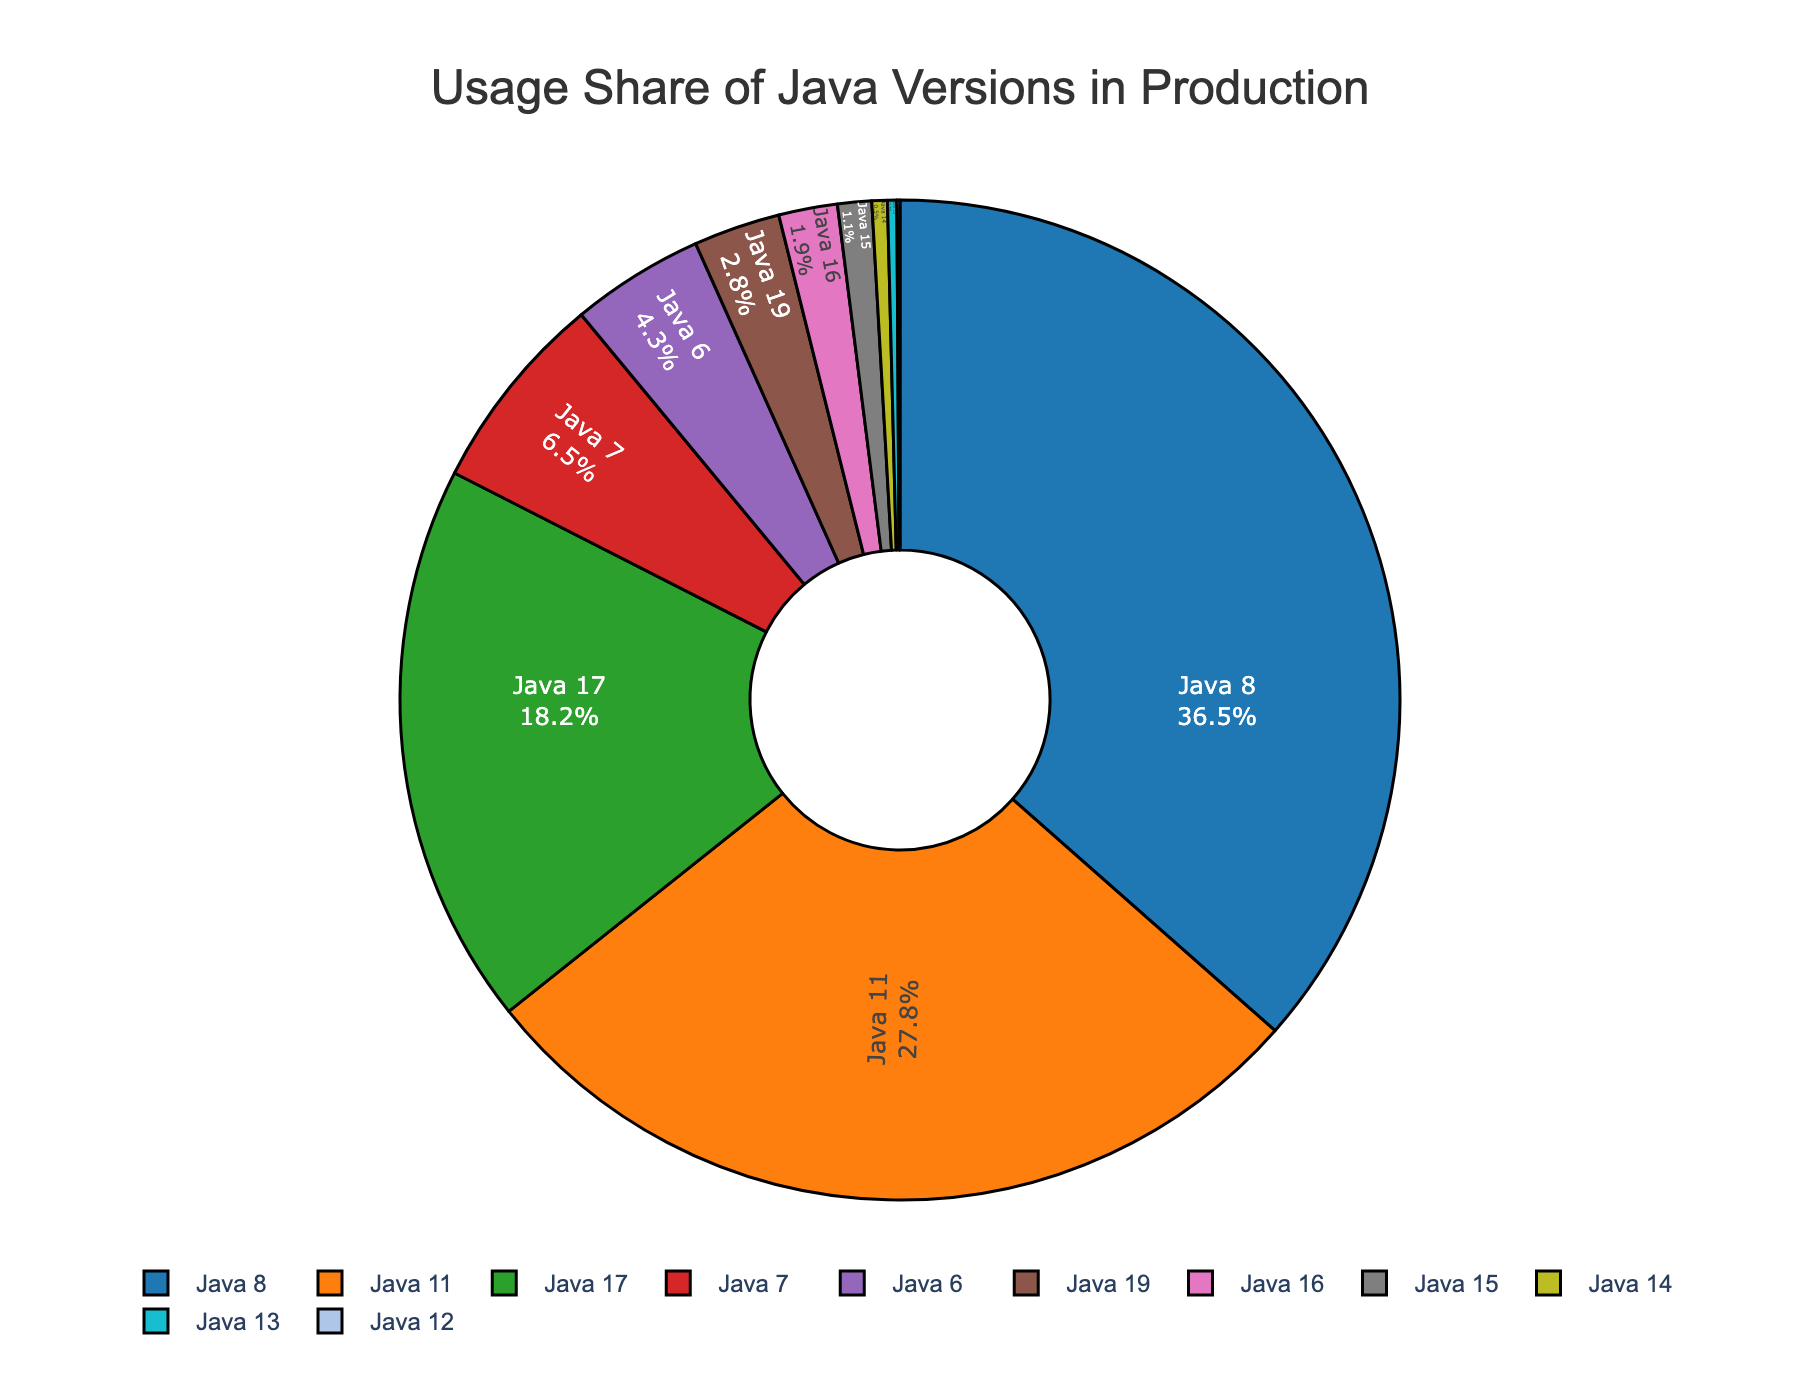What is the most used Java version in production? The figure shows that Java 8 has the largest percentage share, indicating it is the most used.
Answer: Java 8 How much more usage share does Java 11 have compared to Java 17? The figure shows Java 11 has a usage share of 27.8% and Java 17 has 18.2%. The difference is calculated by subtracting 18.2 from 27.8.
Answer: 9.6% Which Java version has the smallest usage share, and what is its percentage? By looking at the smallest segment in the pie chart, Java 12 has the smallest usage share.
Answer: Java 12, 0.1% Sum the usage shares of Java 6 and Java 7. According to the figure, Java 6 has a usage share of 4.3% and Java 7 has 6.5%. Adding these together gives us 4.3 + 6.5.
Answer: 10.8% What percentage of the market do Java versions released after Java 8 (i.e., Java 9+) hold collectively? Summing the percentages of Java versions 9 and higher from the figure: Java 11 (27.8%), Java 17 (18.2%), Java 19 (2.8%), Java 16 (1.9%), Java 15 (1.1%), Java 14 (0.5%), Java 13 (0.3%), Java 12 (0.1%) gives a total of 52.7%.
Answer: 52.7% Which versions of Java have less than 5% usage share? From the figure, Java 6 (4.3%), Java 19 (2.8%), Java 16 (1.9%), Java 15 (1.1%), Java 14 (0.5%), Java 13 (0.3%), and Java 12 (0.1%) all have less than 5%.
Answer: Java 6, Java 19, Java 16, Java 15, Java 14, Java 13, Java 12 Compare the usage of the top three Java versions. Which one has the second highest usage? Java 8 is the highest, Java 11 is the second highest, and Java 17 is the third based on the pie chart segments.
Answer: Java 11 How much more popular is Java 8 compared to Java 6 in terms of usage share? The figure shows Java 8 has a usage share of 36.5% and Java 6 has 4.3%. Subtracting 4.3 from 36.5 gives the difference.
Answer: 32.2% What is the combined usage share for the versions that have a share of exactly 1% or less? Adding the usage shares of Java 15 (1.1%), Java 14 (0.5%), Java 13 (0.3%), and Java 12 (0.1%), we get 2.0%.
Answer: 2.0% What color represents Java 11 in the pie chart? The pie chart uses distinct colors for each segment, and Java 11 is represented by the second segment color, which is orange.
Answer: Orange 